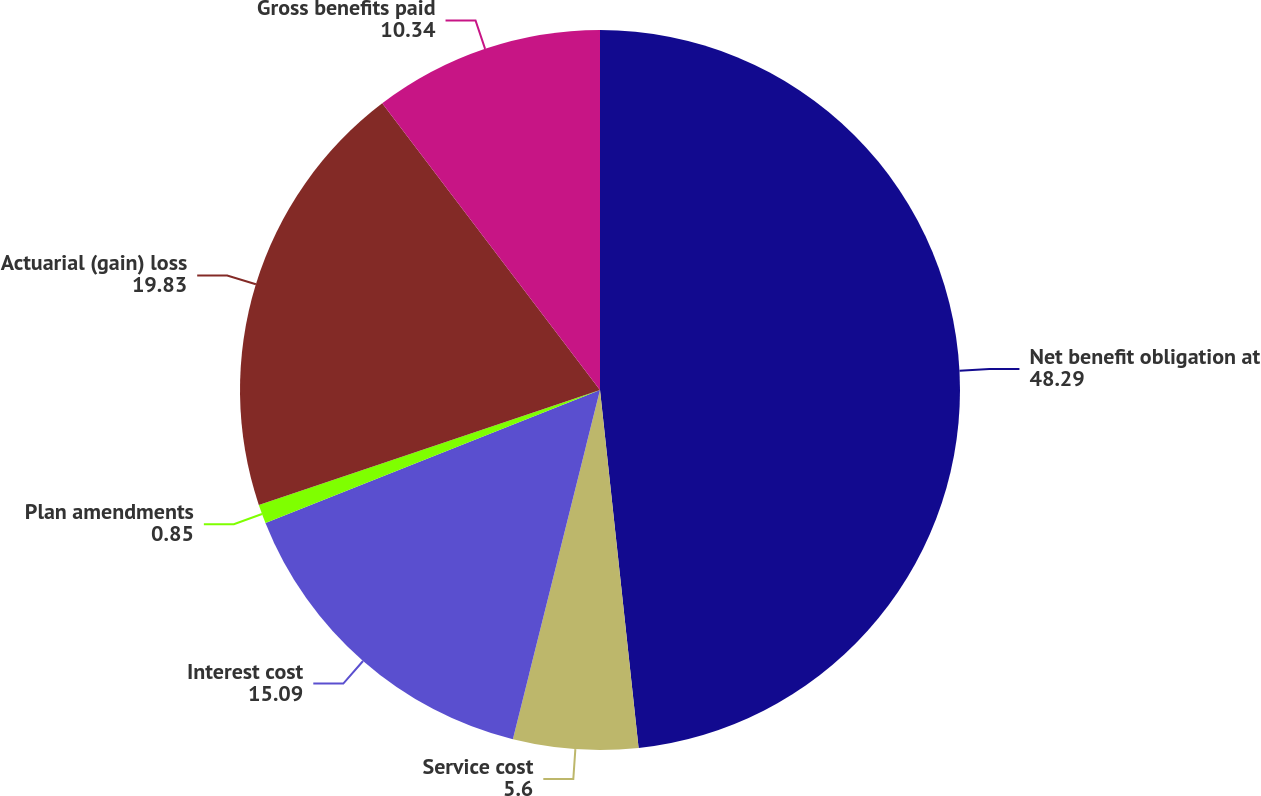<chart> <loc_0><loc_0><loc_500><loc_500><pie_chart><fcel>Net benefit obligation at<fcel>Service cost<fcel>Interest cost<fcel>Plan amendments<fcel>Actuarial (gain) loss<fcel>Gross benefits paid<nl><fcel>48.29%<fcel>5.6%<fcel>15.09%<fcel>0.85%<fcel>19.83%<fcel>10.34%<nl></chart> 